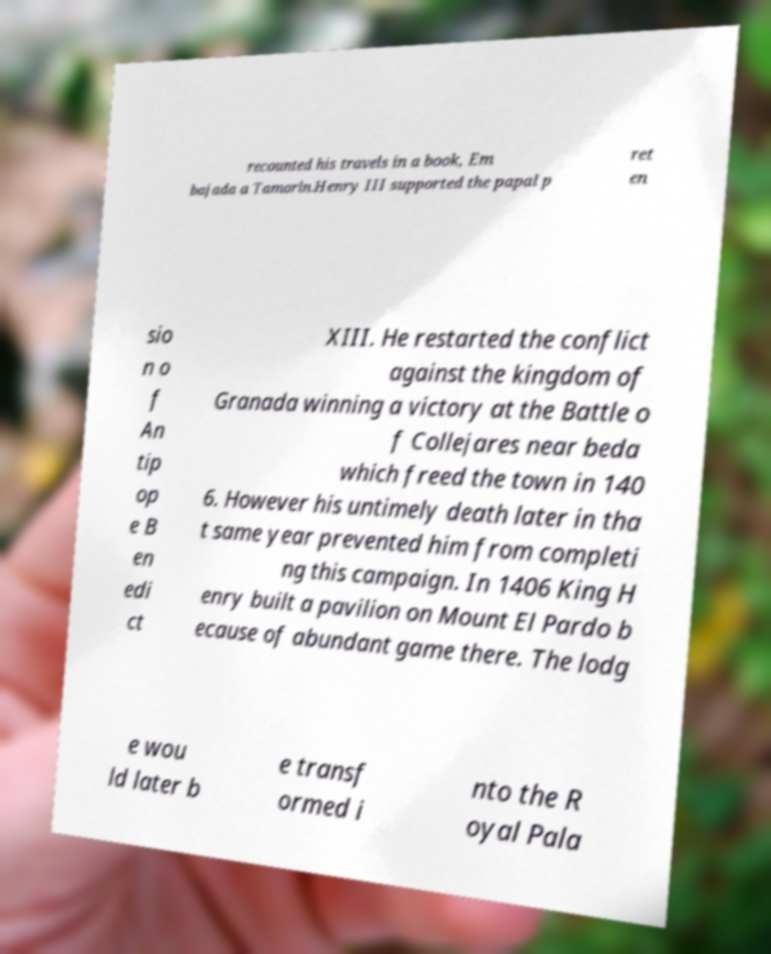Can you accurately transcribe the text from the provided image for me? recounted his travels in a book, Em bajada a Tamorln.Henry III supported the papal p ret en sio n o f An tip op e B en edi ct XIII. He restarted the conflict against the kingdom of Granada winning a victory at the Battle o f Collejares near beda which freed the town in 140 6. However his untimely death later in tha t same year prevented him from completi ng this campaign. In 1406 King H enry built a pavilion on Mount El Pardo b ecause of abundant game there. The lodg e wou ld later b e transf ormed i nto the R oyal Pala 